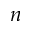Convert formula to latex. <formula><loc_0><loc_0><loc_500><loc_500>n</formula> 